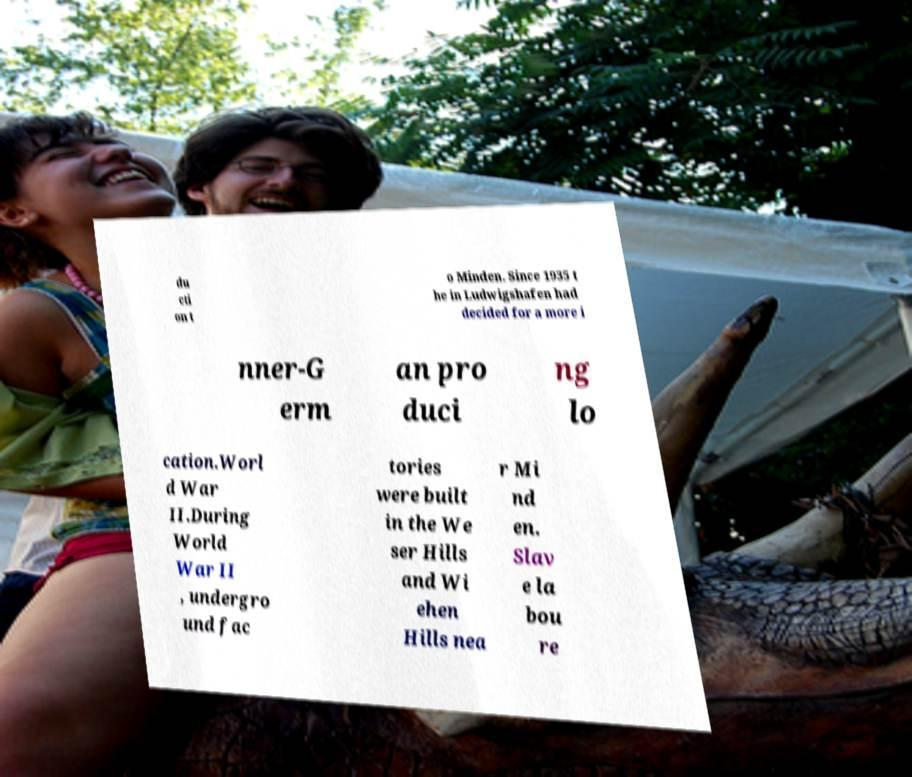Can you accurately transcribe the text from the provided image for me? du cti on t o Minden. Since 1935 t he in Ludwigshafen had decided for a more i nner-G erm an pro duci ng lo cation.Worl d War II.During World War II , undergro und fac tories were built in the We ser Hills and Wi ehen Hills nea r Mi nd en. Slav e la bou re 